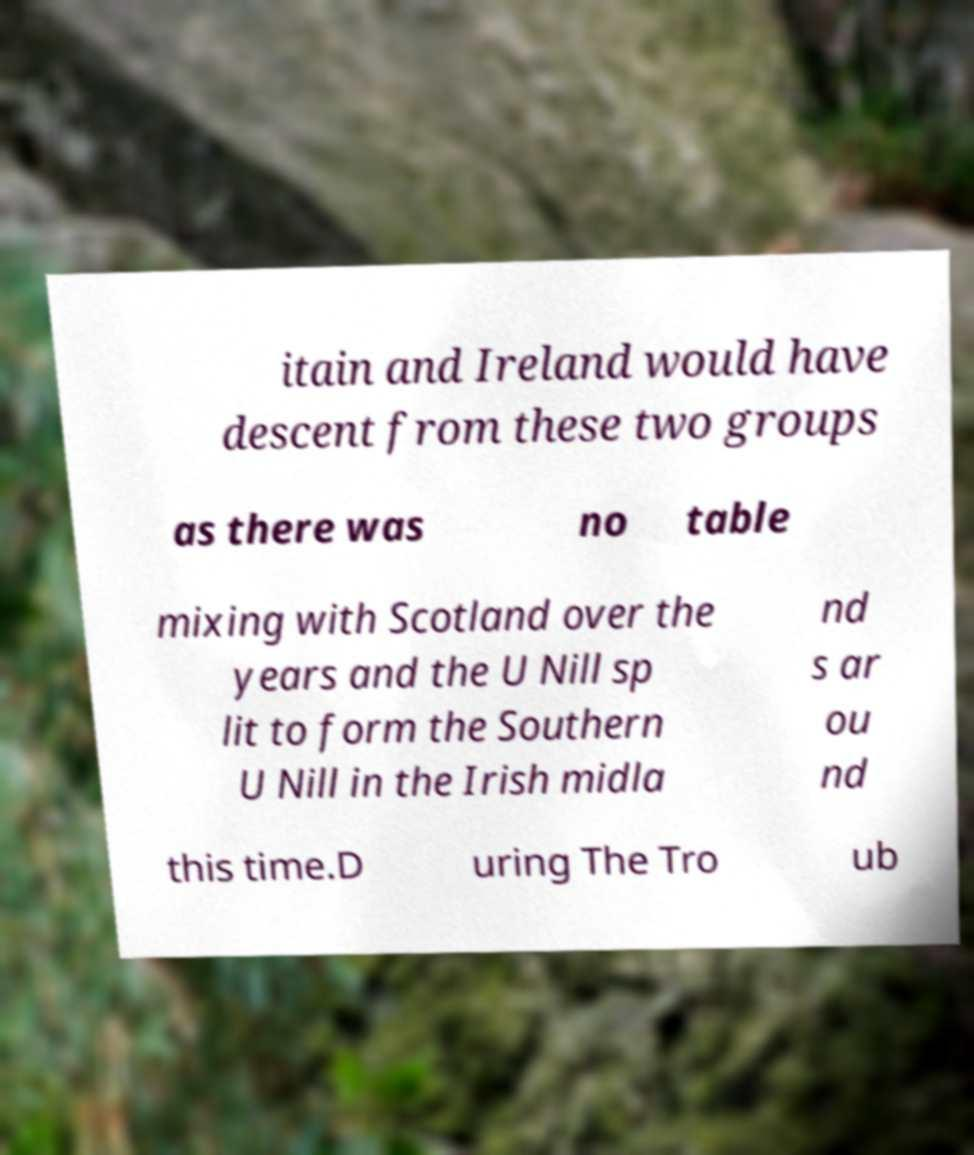What messages or text are displayed in this image? I need them in a readable, typed format. itain and Ireland would have descent from these two groups as there was no table mixing with Scotland over the years and the U Nill sp lit to form the Southern U Nill in the Irish midla nd s ar ou nd this time.D uring The Tro ub 